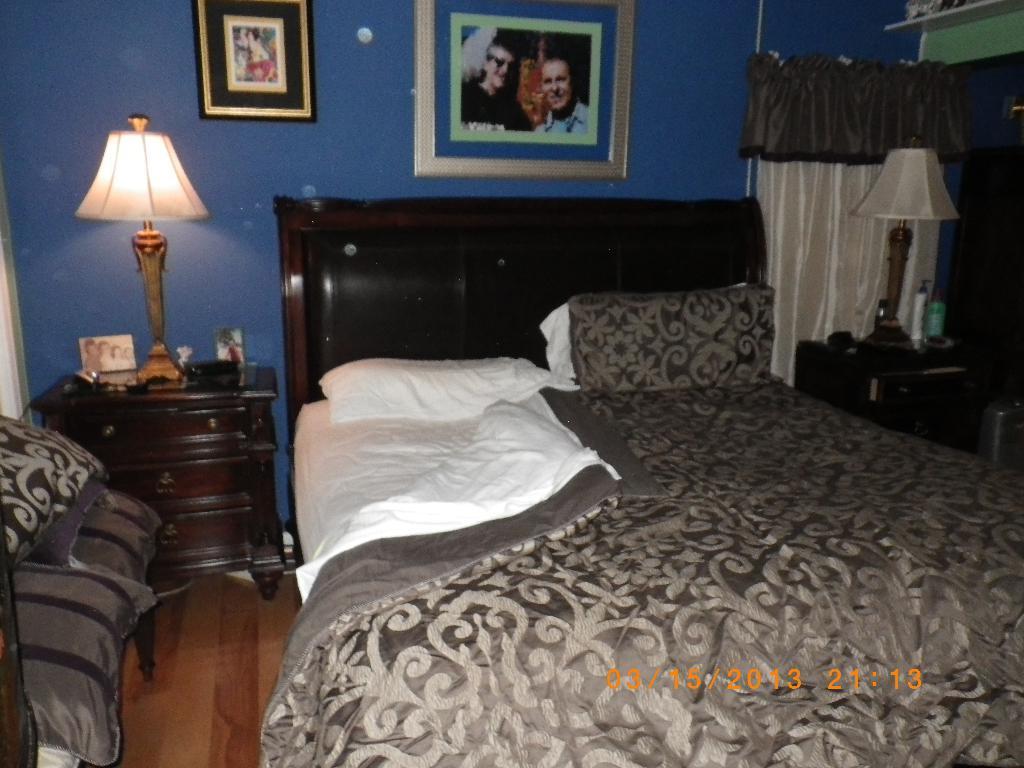In one or two sentences, can you explain what this image depicts? In this image i can see a bed at left i can see a lamp on a cup board at the back ground i can see a frame attached to a wall and a curtain. 